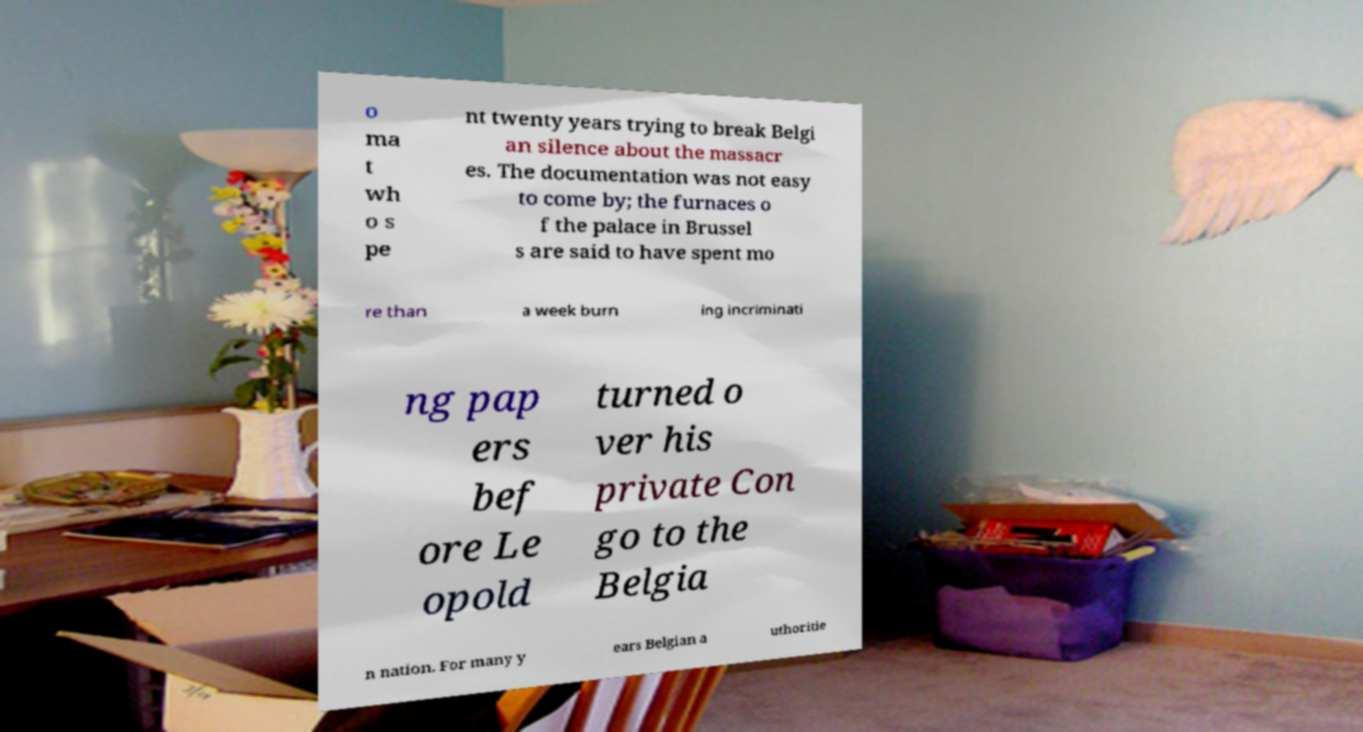Please identify and transcribe the text found in this image. o ma t wh o s pe nt twenty years trying to break Belgi an silence about the massacr es. The documentation was not easy to come by; the furnaces o f the palace in Brussel s are said to have spent mo re than a week burn ing incriminati ng pap ers bef ore Le opold turned o ver his private Con go to the Belgia n nation. For many y ears Belgian a uthoritie 